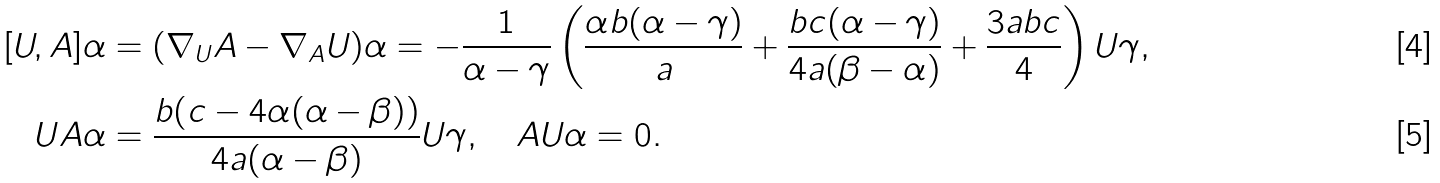Convert formula to latex. <formula><loc_0><loc_0><loc_500><loc_500>[ U , A ] \alpha & = ( \nabla _ { U } A - \nabla _ { A } U ) \alpha = - \frac { 1 } { \alpha - \gamma } \left ( \frac { \alpha b ( \alpha - \gamma ) } { a } + \frac { b c ( \alpha - \gamma ) } { 4 a ( \beta - \alpha ) } + \frac { 3 a b c } { 4 } \right ) U \gamma , \\ U A \alpha & = \frac { b ( c - 4 \alpha ( \alpha - \beta ) ) } { 4 a ( \alpha - \beta ) } U \gamma , \quad A U \alpha = 0 .</formula> 